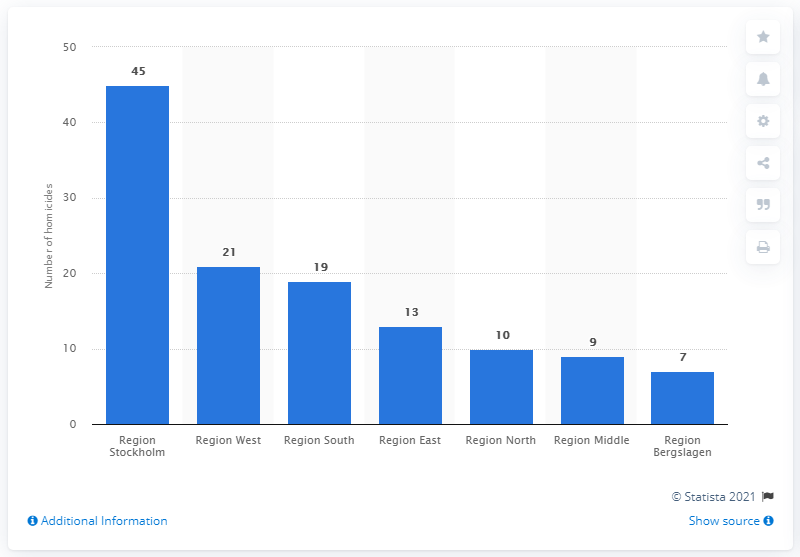Indicate a few pertinent items in this graphic. According to the data from 2020, the region of West in Sweden had the second highest number of homicides among all regions in the country. In 2020, 45 homicide-related deaths were reported in Stockholm. There were 21 homicides registered in Region West in 2020. 